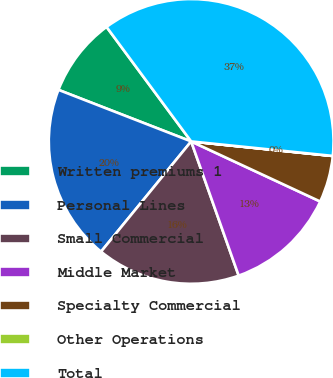<chart> <loc_0><loc_0><loc_500><loc_500><pie_chart><fcel>Written premiums 1<fcel>Personal Lines<fcel>Small Commercial<fcel>Middle Market<fcel>Specialty Commercial<fcel>Other Operations<fcel>Total<nl><fcel>8.97%<fcel>19.99%<fcel>16.32%<fcel>12.65%<fcel>5.3%<fcel>0.01%<fcel>36.75%<nl></chart> 